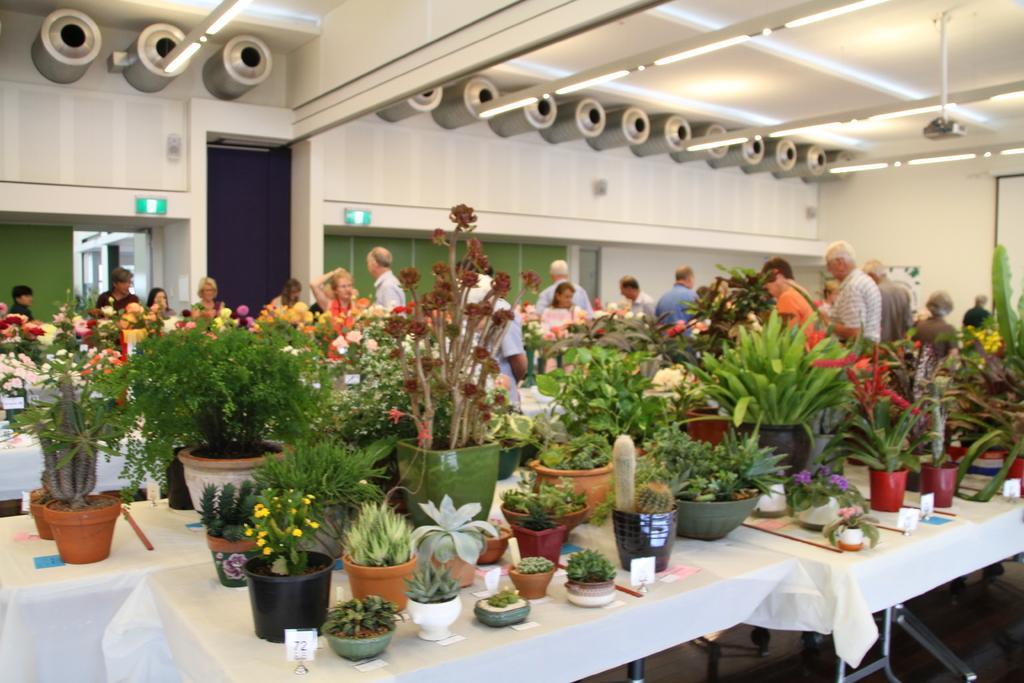In one or two sentences, can you explain what this image depicts? In the center of the image we can see planets placed on the tables. In the background there are persons, plants, lights, door, projector, screen and wall. 